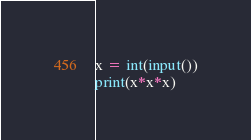<code> <loc_0><loc_0><loc_500><loc_500><_Python_>x = int(input())
print(x*x*x)
</code> 